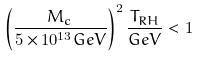<formula> <loc_0><loc_0><loc_500><loc_500>\left ( \frac { M _ { c } } { 5 \times 1 0 ^ { 1 3 } G e V } \right ) ^ { 2 } \frac { T _ { R H } } { G e V } < 1</formula> 